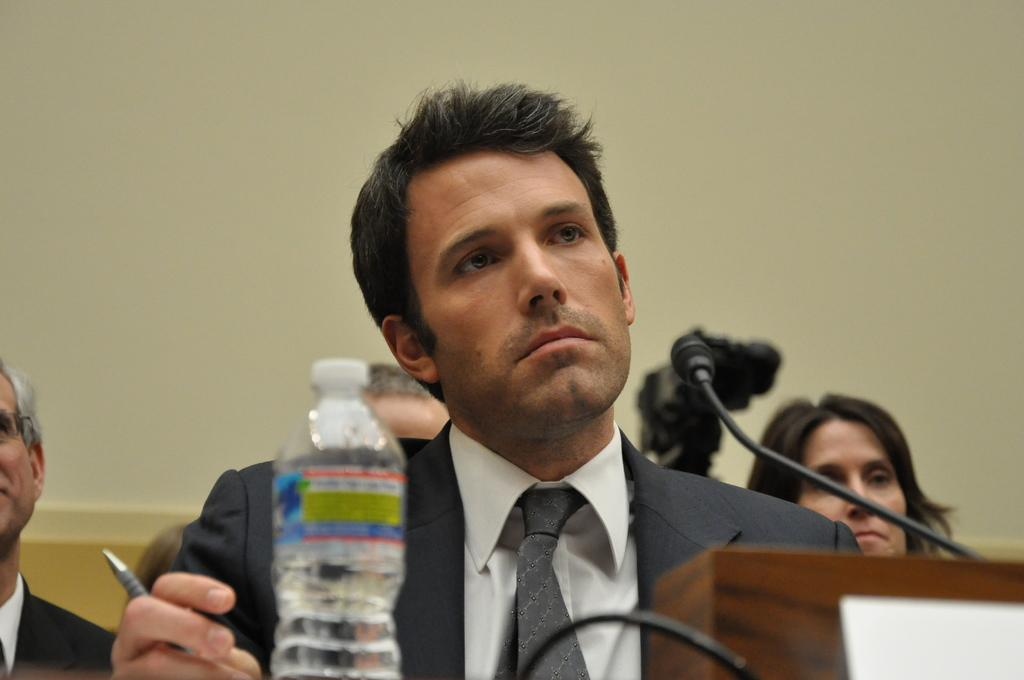Who is the main subject in the image? There is a man in the image. Where is the man located in the image? The man is sitting in a conference room. Are there any other people present in the image? Yes, there are people behind the man in the image. What type of wood is the fork made of in the image? There is no fork present in the image, so it is not possible to determine what type of wood it might be made of. 